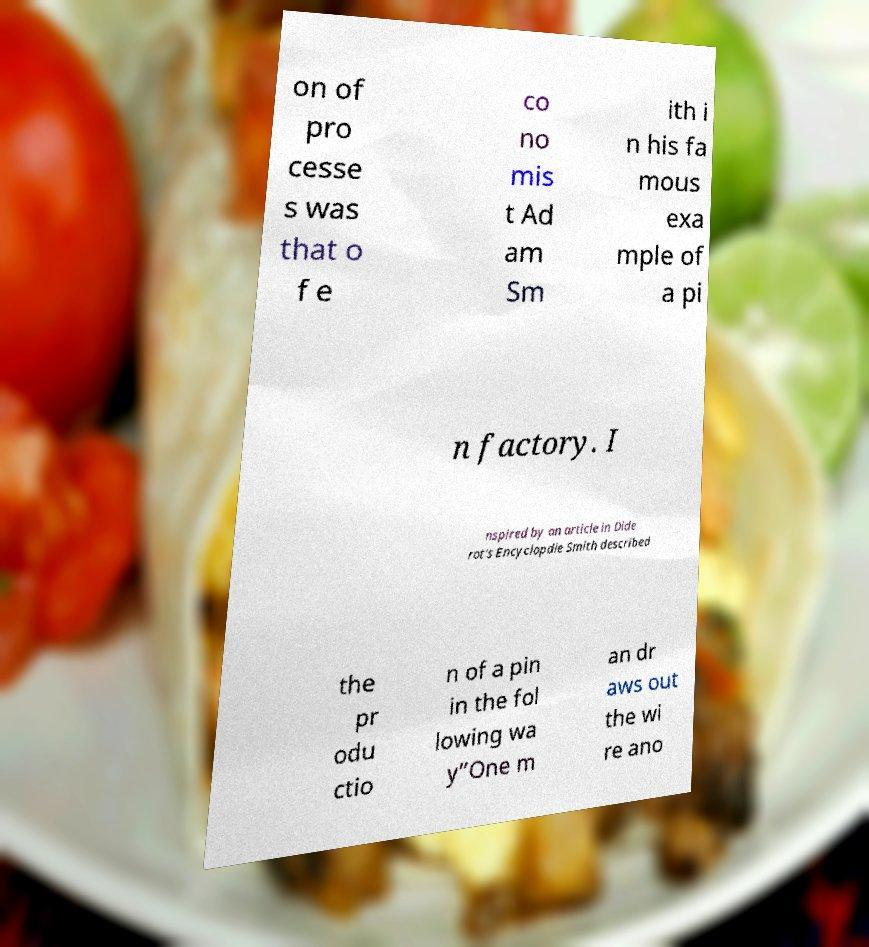Can you accurately transcribe the text from the provided image for me? on of pro cesse s was that o f e co no mis t Ad am Sm ith i n his fa mous exa mple of a pi n factory. I nspired by an article in Dide rot's Encyclopdie Smith described the pr odu ctio n of a pin in the fol lowing wa y”One m an dr aws out the wi re ano 